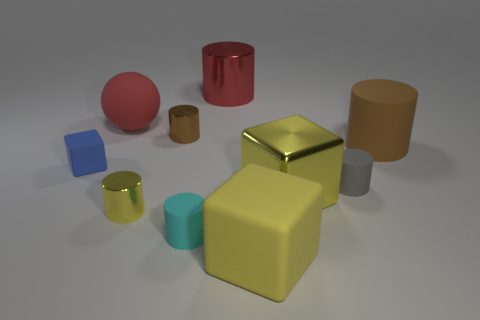There is a small object to the left of the large red matte object; is it the same shape as the gray rubber object?
Keep it short and to the point. No. How many objects are tiny shiny objects in front of the gray rubber thing or big yellow rubber balls?
Your answer should be very brief. 1. Are there any small purple matte objects of the same shape as the tiny brown object?
Make the answer very short. No. What is the shape of the blue object that is the same size as the yellow metal cylinder?
Provide a succinct answer. Cube. The large metallic object that is behind the tiny shiny thing behind the brown thing that is on the right side of the small gray rubber cylinder is what shape?
Offer a terse response. Cylinder. Do the brown shiny thing and the tiny cyan matte thing in front of the small yellow object have the same shape?
Offer a terse response. Yes. How many small things are blue matte objects or shiny cylinders?
Your answer should be compact. 3. Are there any yellow shiny things that have the same size as the blue rubber block?
Keep it short and to the point. Yes. The matte cube behind the rubber block that is right of the matte object behind the brown metallic object is what color?
Provide a succinct answer. Blue. Is the material of the small block the same as the yellow thing that is behind the small yellow metal cylinder?
Offer a terse response. No. 